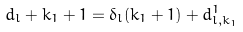Convert formula to latex. <formula><loc_0><loc_0><loc_500><loc_500>d _ { l } + k _ { 1 } + 1 = \delta _ { l } ( k _ { 1 } + 1 ) + d _ { l , k _ { 1 } } ^ { 1 }</formula> 